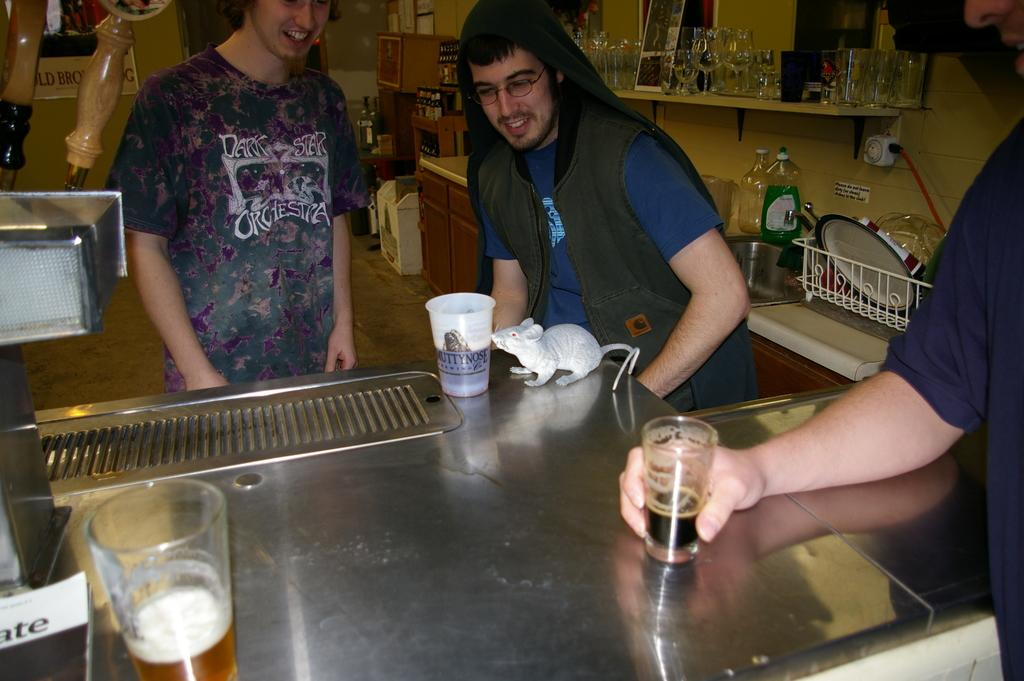What type of animal can be seen in the image? There is a mouse in the image. What material is the surface that the mouse is on? There is a stainless steel surface in the image. What cooking appliance is present in the image? There is a grill in the image. What type of beverage is being served in the glasses? The glasses are filled with wine in the image. What type of storage unit is present in the image? There is a wooden drawer in the image. What type of containers are present in the image? There are bottles in the image. Can you describe any other objects present in the image? There are other objects in the image, but their specific details are not mentioned in the provided facts. What letters are being used to spell out a word on the stove in the image? There is no stove present in the image, and therefore no letters can be observed on it. 